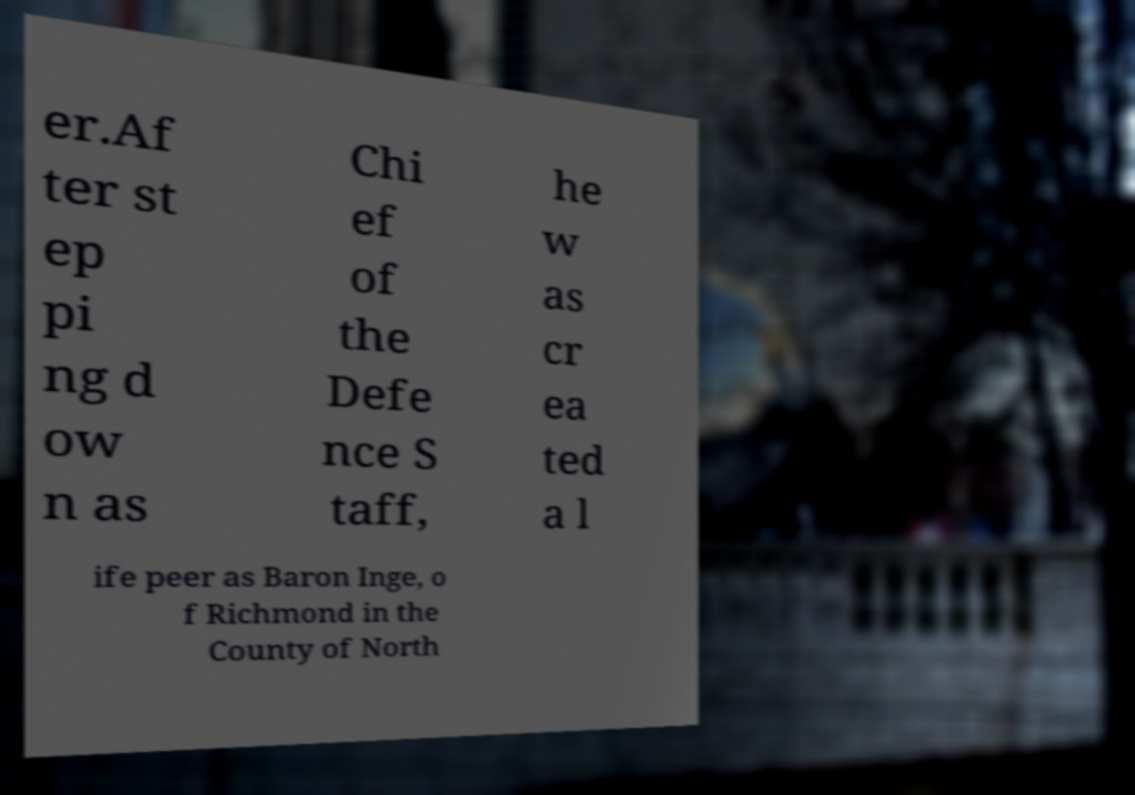What messages or text are displayed in this image? I need them in a readable, typed format. er.Af ter st ep pi ng d ow n as Chi ef of the Defe nce S taff, he w as cr ea ted a l ife peer as Baron Inge, o f Richmond in the County of North 